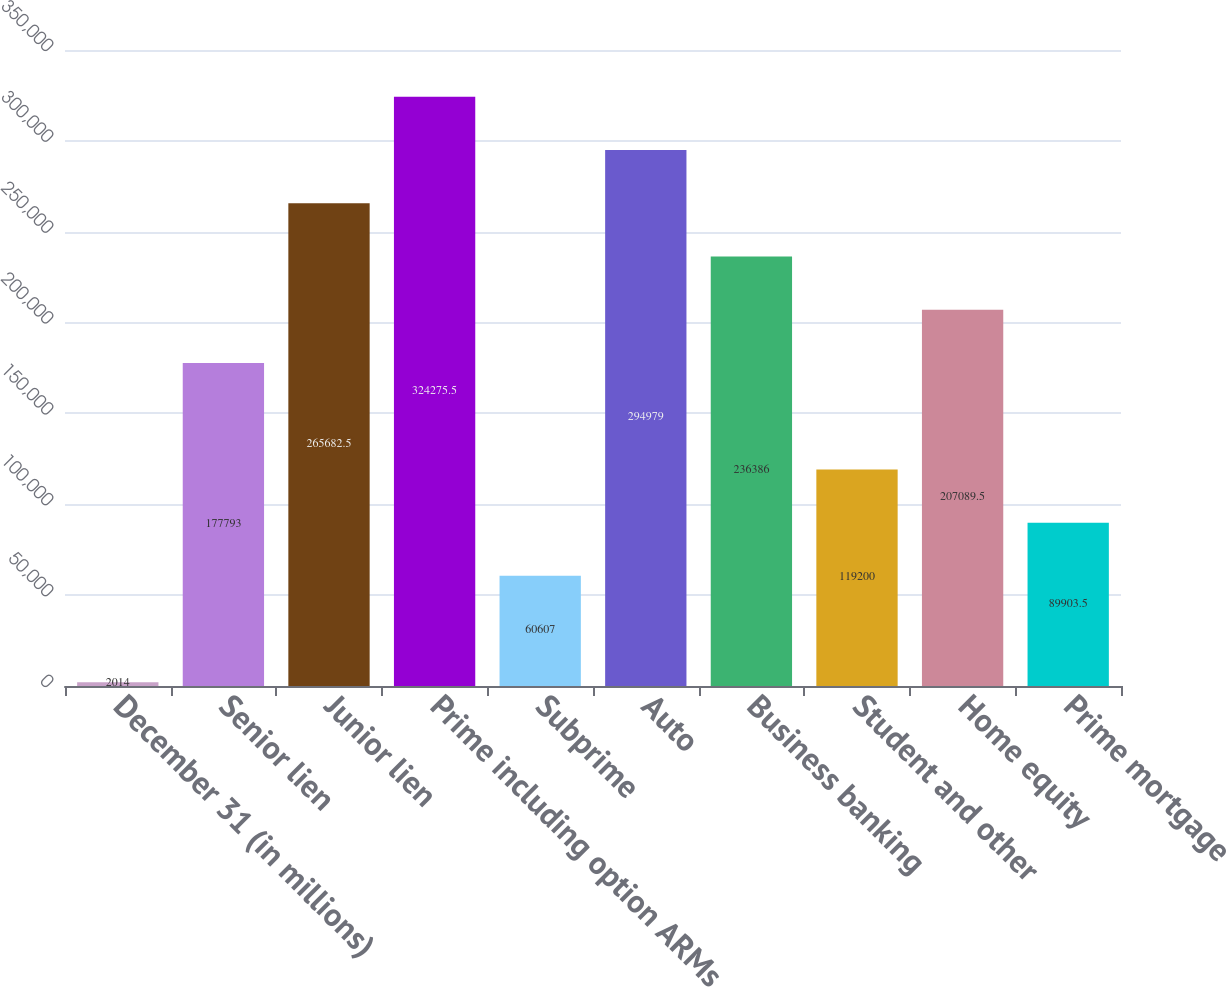<chart> <loc_0><loc_0><loc_500><loc_500><bar_chart><fcel>December 31 (in millions)<fcel>Senior lien<fcel>Junior lien<fcel>Prime including option ARMs<fcel>Subprime<fcel>Auto<fcel>Business banking<fcel>Student and other<fcel>Home equity<fcel>Prime mortgage<nl><fcel>2014<fcel>177793<fcel>265682<fcel>324276<fcel>60607<fcel>294979<fcel>236386<fcel>119200<fcel>207090<fcel>89903.5<nl></chart> 